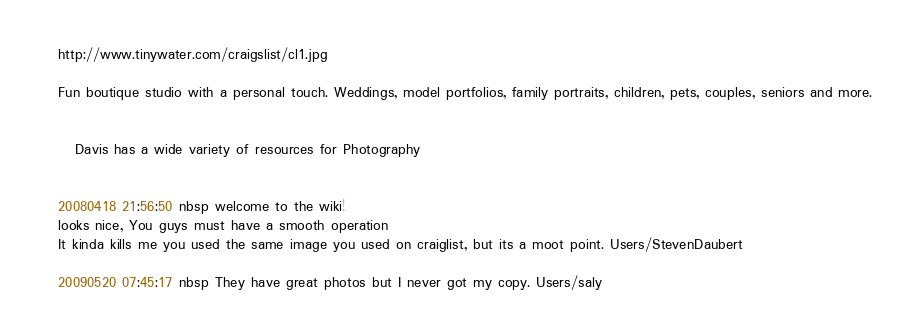Convert code to text. <code><loc_0><loc_0><loc_500><loc_500><_FORTRAN_>http://www.tinywater.com/craigslist/cl1.jpg

Fun boutique studio with a personal touch. Weddings, model portfolios, family portraits, children, pets, couples, seniors and more.


   Davis has a wide variety of resources for Photography


20080418 21:56:50 nbsp welcome to the wiki!
looks nice, You guys must have a smooth operation
It kinda kills me you used the same image you used on craiglist, but its a moot point. Users/StevenDaubert

20090520 07:45:17 nbsp They have great photos but I never got my copy. Users/saly
</code> 